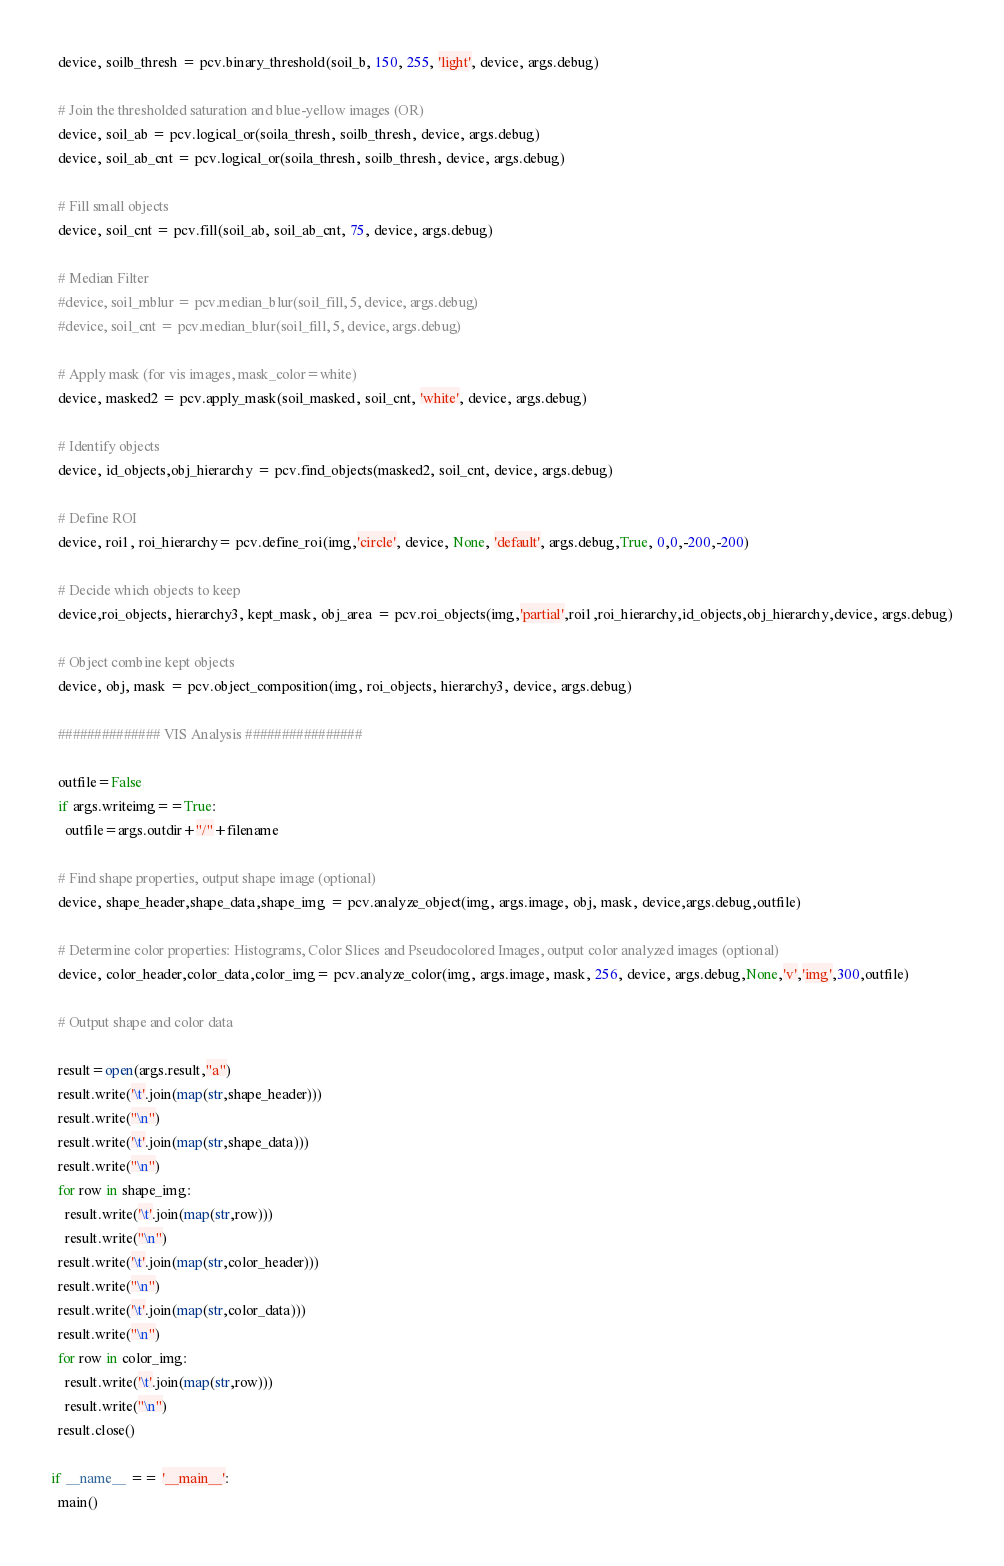Convert code to text. <code><loc_0><loc_0><loc_500><loc_500><_Python_>  device, soilb_thresh = pcv.binary_threshold(soil_b, 150, 255, 'light', device, args.debug)

  # Join the thresholded saturation and blue-yellow images (OR)
  device, soil_ab = pcv.logical_or(soila_thresh, soilb_thresh, device, args.debug)
  device, soil_ab_cnt = pcv.logical_or(soila_thresh, soilb_thresh, device, args.debug)

  # Fill small objects
  device, soil_cnt = pcv.fill(soil_ab, soil_ab_cnt, 75, device, args.debug)

  # Median Filter
  #device, soil_mblur = pcv.median_blur(soil_fill, 5, device, args.debug)
  #device, soil_cnt = pcv.median_blur(soil_fill, 5, device, args.debug)
  
  # Apply mask (for vis images, mask_color=white)
  device, masked2 = pcv.apply_mask(soil_masked, soil_cnt, 'white', device, args.debug)
  
  # Identify objects
  device, id_objects,obj_hierarchy = pcv.find_objects(masked2, soil_cnt, device, args.debug)

  # Define ROI
  device, roi1, roi_hierarchy= pcv.define_roi(img,'circle', device, None, 'default', args.debug,True, 0,0,-200,-200)
  
  # Decide which objects to keep
  device,roi_objects, hierarchy3, kept_mask, obj_area = pcv.roi_objects(img,'partial',roi1,roi_hierarchy,id_objects,obj_hierarchy,device, args.debug)
  
  # Object combine kept objects
  device, obj, mask = pcv.object_composition(img, roi_objects, hierarchy3, device, args.debug)
  
  ############## VIS Analysis ################
  
  outfile=False
  if args.writeimg==True:
    outfile=args.outdir+"/"+filename
  
  # Find shape properties, output shape image (optional)
  device, shape_header,shape_data,shape_img = pcv.analyze_object(img, args.image, obj, mask, device,args.debug,outfile)
    
  # Determine color properties: Histograms, Color Slices and Pseudocolored Images, output color analyzed images (optional)
  device, color_header,color_data,color_img= pcv.analyze_color(img, args.image, mask, 256, device, args.debug,None,'v','img',300,outfile)
  
  # Output shape and color data

  result=open(args.result,"a")
  result.write('\t'.join(map(str,shape_header)))
  result.write("\n")
  result.write('\t'.join(map(str,shape_data)))
  result.write("\n")
  for row in shape_img:
    result.write('\t'.join(map(str,row)))
    result.write("\n")
  result.write('\t'.join(map(str,color_header)))
  result.write("\n")
  result.write('\t'.join(map(str,color_data)))
  result.write("\n")
  for row in color_img:
    result.write('\t'.join(map(str,row)))
    result.write("\n")
  result.close()
  
if __name__ == '__main__':
  main()</code> 